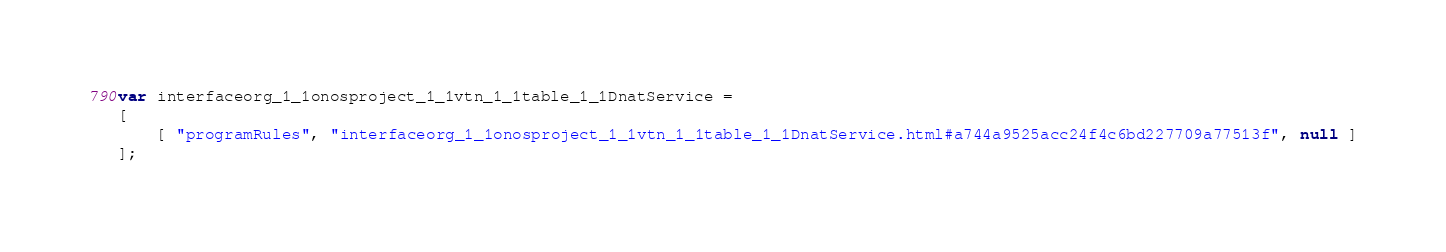Convert code to text. <code><loc_0><loc_0><loc_500><loc_500><_JavaScript_>var interfaceorg_1_1onosproject_1_1vtn_1_1table_1_1DnatService =
[
    [ "programRules", "interfaceorg_1_1onosproject_1_1vtn_1_1table_1_1DnatService.html#a744a9525acc24f4c6bd227709a77513f", null ]
];</code> 